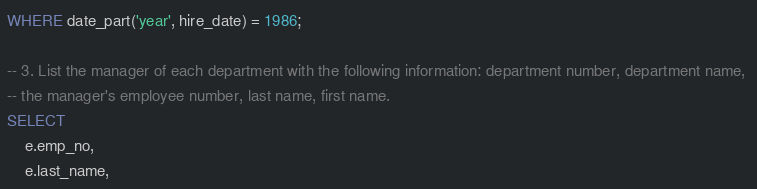Convert code to text. <code><loc_0><loc_0><loc_500><loc_500><_SQL_>WHERE date_part('year', hire_date) = 1986;

-- 3. List the manager of each department with the following information: department number, department name, 
-- the manager's employee number, last name, first name.
SELECT
    e.emp_no,
    e.last_name,</code> 